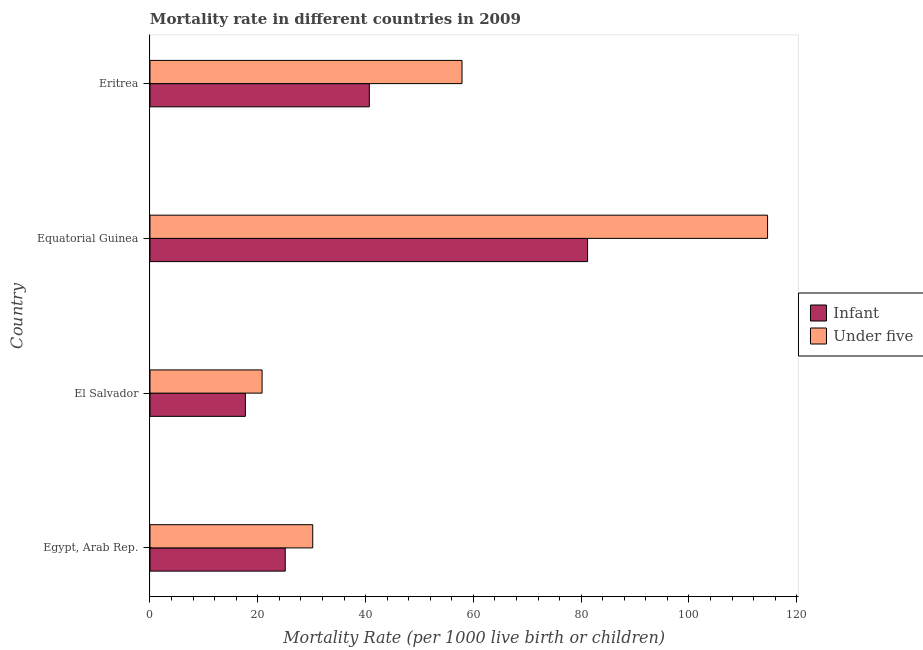How many groups of bars are there?
Offer a very short reply. 4. How many bars are there on the 2nd tick from the bottom?
Make the answer very short. 2. What is the label of the 2nd group of bars from the top?
Offer a terse response. Equatorial Guinea. In how many cases, is the number of bars for a given country not equal to the number of legend labels?
Make the answer very short. 0. What is the infant mortality rate in Equatorial Guinea?
Your answer should be compact. 81.2. Across all countries, what is the maximum infant mortality rate?
Provide a short and direct response. 81.2. Across all countries, what is the minimum under-5 mortality rate?
Ensure brevity in your answer.  20.8. In which country was the infant mortality rate maximum?
Offer a very short reply. Equatorial Guinea. In which country was the under-5 mortality rate minimum?
Your answer should be compact. El Salvador. What is the total under-5 mortality rate in the graph?
Provide a short and direct response. 223.5. What is the difference between the under-5 mortality rate in Egypt, Arab Rep. and that in Equatorial Guinea?
Give a very brief answer. -84.4. What is the difference between the infant mortality rate in Eritrea and the under-5 mortality rate in Egypt, Arab Rep.?
Ensure brevity in your answer.  10.5. What is the average under-5 mortality rate per country?
Offer a terse response. 55.88. What is the difference between the under-5 mortality rate and infant mortality rate in Eritrea?
Make the answer very short. 17.2. In how many countries, is the under-5 mortality rate greater than 48 ?
Provide a short and direct response. 2. What is the ratio of the under-5 mortality rate in El Salvador to that in Eritrea?
Provide a succinct answer. 0.36. Is the infant mortality rate in El Salvador less than that in Equatorial Guinea?
Give a very brief answer. Yes. What is the difference between the highest and the second highest under-5 mortality rate?
Keep it short and to the point. 56.7. What is the difference between the highest and the lowest infant mortality rate?
Give a very brief answer. 63.5. What does the 1st bar from the top in Equatorial Guinea represents?
Keep it short and to the point. Under five. What does the 2nd bar from the bottom in Egypt, Arab Rep. represents?
Make the answer very short. Under five. Are the values on the major ticks of X-axis written in scientific E-notation?
Ensure brevity in your answer.  No. Does the graph contain any zero values?
Provide a succinct answer. No. Does the graph contain grids?
Ensure brevity in your answer.  No. What is the title of the graph?
Your response must be concise. Mortality rate in different countries in 2009. What is the label or title of the X-axis?
Provide a succinct answer. Mortality Rate (per 1000 live birth or children). What is the Mortality Rate (per 1000 live birth or children) in Infant in Egypt, Arab Rep.?
Your response must be concise. 25.1. What is the Mortality Rate (per 1000 live birth or children) in Under five in Egypt, Arab Rep.?
Keep it short and to the point. 30.2. What is the Mortality Rate (per 1000 live birth or children) in Infant in El Salvador?
Provide a succinct answer. 17.7. What is the Mortality Rate (per 1000 live birth or children) of Under five in El Salvador?
Offer a very short reply. 20.8. What is the Mortality Rate (per 1000 live birth or children) of Infant in Equatorial Guinea?
Provide a succinct answer. 81.2. What is the Mortality Rate (per 1000 live birth or children) in Under five in Equatorial Guinea?
Give a very brief answer. 114.6. What is the Mortality Rate (per 1000 live birth or children) of Infant in Eritrea?
Ensure brevity in your answer.  40.7. What is the Mortality Rate (per 1000 live birth or children) of Under five in Eritrea?
Keep it short and to the point. 57.9. Across all countries, what is the maximum Mortality Rate (per 1000 live birth or children) of Infant?
Offer a terse response. 81.2. Across all countries, what is the maximum Mortality Rate (per 1000 live birth or children) of Under five?
Provide a short and direct response. 114.6. Across all countries, what is the minimum Mortality Rate (per 1000 live birth or children) in Infant?
Keep it short and to the point. 17.7. Across all countries, what is the minimum Mortality Rate (per 1000 live birth or children) in Under five?
Give a very brief answer. 20.8. What is the total Mortality Rate (per 1000 live birth or children) of Infant in the graph?
Your answer should be very brief. 164.7. What is the total Mortality Rate (per 1000 live birth or children) in Under five in the graph?
Give a very brief answer. 223.5. What is the difference between the Mortality Rate (per 1000 live birth or children) in Infant in Egypt, Arab Rep. and that in El Salvador?
Make the answer very short. 7.4. What is the difference between the Mortality Rate (per 1000 live birth or children) in Infant in Egypt, Arab Rep. and that in Equatorial Guinea?
Your response must be concise. -56.1. What is the difference between the Mortality Rate (per 1000 live birth or children) in Under five in Egypt, Arab Rep. and that in Equatorial Guinea?
Offer a terse response. -84.4. What is the difference between the Mortality Rate (per 1000 live birth or children) in Infant in Egypt, Arab Rep. and that in Eritrea?
Make the answer very short. -15.6. What is the difference between the Mortality Rate (per 1000 live birth or children) of Under five in Egypt, Arab Rep. and that in Eritrea?
Ensure brevity in your answer.  -27.7. What is the difference between the Mortality Rate (per 1000 live birth or children) of Infant in El Salvador and that in Equatorial Guinea?
Provide a short and direct response. -63.5. What is the difference between the Mortality Rate (per 1000 live birth or children) in Under five in El Salvador and that in Equatorial Guinea?
Give a very brief answer. -93.8. What is the difference between the Mortality Rate (per 1000 live birth or children) in Under five in El Salvador and that in Eritrea?
Provide a short and direct response. -37.1. What is the difference between the Mortality Rate (per 1000 live birth or children) in Infant in Equatorial Guinea and that in Eritrea?
Make the answer very short. 40.5. What is the difference between the Mortality Rate (per 1000 live birth or children) of Under five in Equatorial Guinea and that in Eritrea?
Your answer should be compact. 56.7. What is the difference between the Mortality Rate (per 1000 live birth or children) of Infant in Egypt, Arab Rep. and the Mortality Rate (per 1000 live birth or children) of Under five in Equatorial Guinea?
Your answer should be very brief. -89.5. What is the difference between the Mortality Rate (per 1000 live birth or children) of Infant in Egypt, Arab Rep. and the Mortality Rate (per 1000 live birth or children) of Under five in Eritrea?
Your response must be concise. -32.8. What is the difference between the Mortality Rate (per 1000 live birth or children) in Infant in El Salvador and the Mortality Rate (per 1000 live birth or children) in Under five in Equatorial Guinea?
Provide a short and direct response. -96.9. What is the difference between the Mortality Rate (per 1000 live birth or children) in Infant in El Salvador and the Mortality Rate (per 1000 live birth or children) in Under five in Eritrea?
Provide a short and direct response. -40.2. What is the difference between the Mortality Rate (per 1000 live birth or children) of Infant in Equatorial Guinea and the Mortality Rate (per 1000 live birth or children) of Under five in Eritrea?
Provide a succinct answer. 23.3. What is the average Mortality Rate (per 1000 live birth or children) of Infant per country?
Your answer should be compact. 41.17. What is the average Mortality Rate (per 1000 live birth or children) of Under five per country?
Keep it short and to the point. 55.88. What is the difference between the Mortality Rate (per 1000 live birth or children) in Infant and Mortality Rate (per 1000 live birth or children) in Under five in Egypt, Arab Rep.?
Ensure brevity in your answer.  -5.1. What is the difference between the Mortality Rate (per 1000 live birth or children) in Infant and Mortality Rate (per 1000 live birth or children) in Under five in Equatorial Guinea?
Your response must be concise. -33.4. What is the difference between the Mortality Rate (per 1000 live birth or children) in Infant and Mortality Rate (per 1000 live birth or children) in Under five in Eritrea?
Your answer should be very brief. -17.2. What is the ratio of the Mortality Rate (per 1000 live birth or children) of Infant in Egypt, Arab Rep. to that in El Salvador?
Offer a terse response. 1.42. What is the ratio of the Mortality Rate (per 1000 live birth or children) of Under five in Egypt, Arab Rep. to that in El Salvador?
Keep it short and to the point. 1.45. What is the ratio of the Mortality Rate (per 1000 live birth or children) of Infant in Egypt, Arab Rep. to that in Equatorial Guinea?
Offer a terse response. 0.31. What is the ratio of the Mortality Rate (per 1000 live birth or children) of Under five in Egypt, Arab Rep. to that in Equatorial Guinea?
Provide a succinct answer. 0.26. What is the ratio of the Mortality Rate (per 1000 live birth or children) in Infant in Egypt, Arab Rep. to that in Eritrea?
Your response must be concise. 0.62. What is the ratio of the Mortality Rate (per 1000 live birth or children) of Under five in Egypt, Arab Rep. to that in Eritrea?
Your answer should be very brief. 0.52. What is the ratio of the Mortality Rate (per 1000 live birth or children) of Infant in El Salvador to that in Equatorial Guinea?
Your answer should be compact. 0.22. What is the ratio of the Mortality Rate (per 1000 live birth or children) of Under five in El Salvador to that in Equatorial Guinea?
Provide a short and direct response. 0.18. What is the ratio of the Mortality Rate (per 1000 live birth or children) of Infant in El Salvador to that in Eritrea?
Offer a very short reply. 0.43. What is the ratio of the Mortality Rate (per 1000 live birth or children) in Under five in El Salvador to that in Eritrea?
Your response must be concise. 0.36. What is the ratio of the Mortality Rate (per 1000 live birth or children) in Infant in Equatorial Guinea to that in Eritrea?
Provide a short and direct response. 2. What is the ratio of the Mortality Rate (per 1000 live birth or children) in Under five in Equatorial Guinea to that in Eritrea?
Provide a short and direct response. 1.98. What is the difference between the highest and the second highest Mortality Rate (per 1000 live birth or children) of Infant?
Offer a terse response. 40.5. What is the difference between the highest and the second highest Mortality Rate (per 1000 live birth or children) of Under five?
Keep it short and to the point. 56.7. What is the difference between the highest and the lowest Mortality Rate (per 1000 live birth or children) in Infant?
Give a very brief answer. 63.5. What is the difference between the highest and the lowest Mortality Rate (per 1000 live birth or children) of Under five?
Make the answer very short. 93.8. 